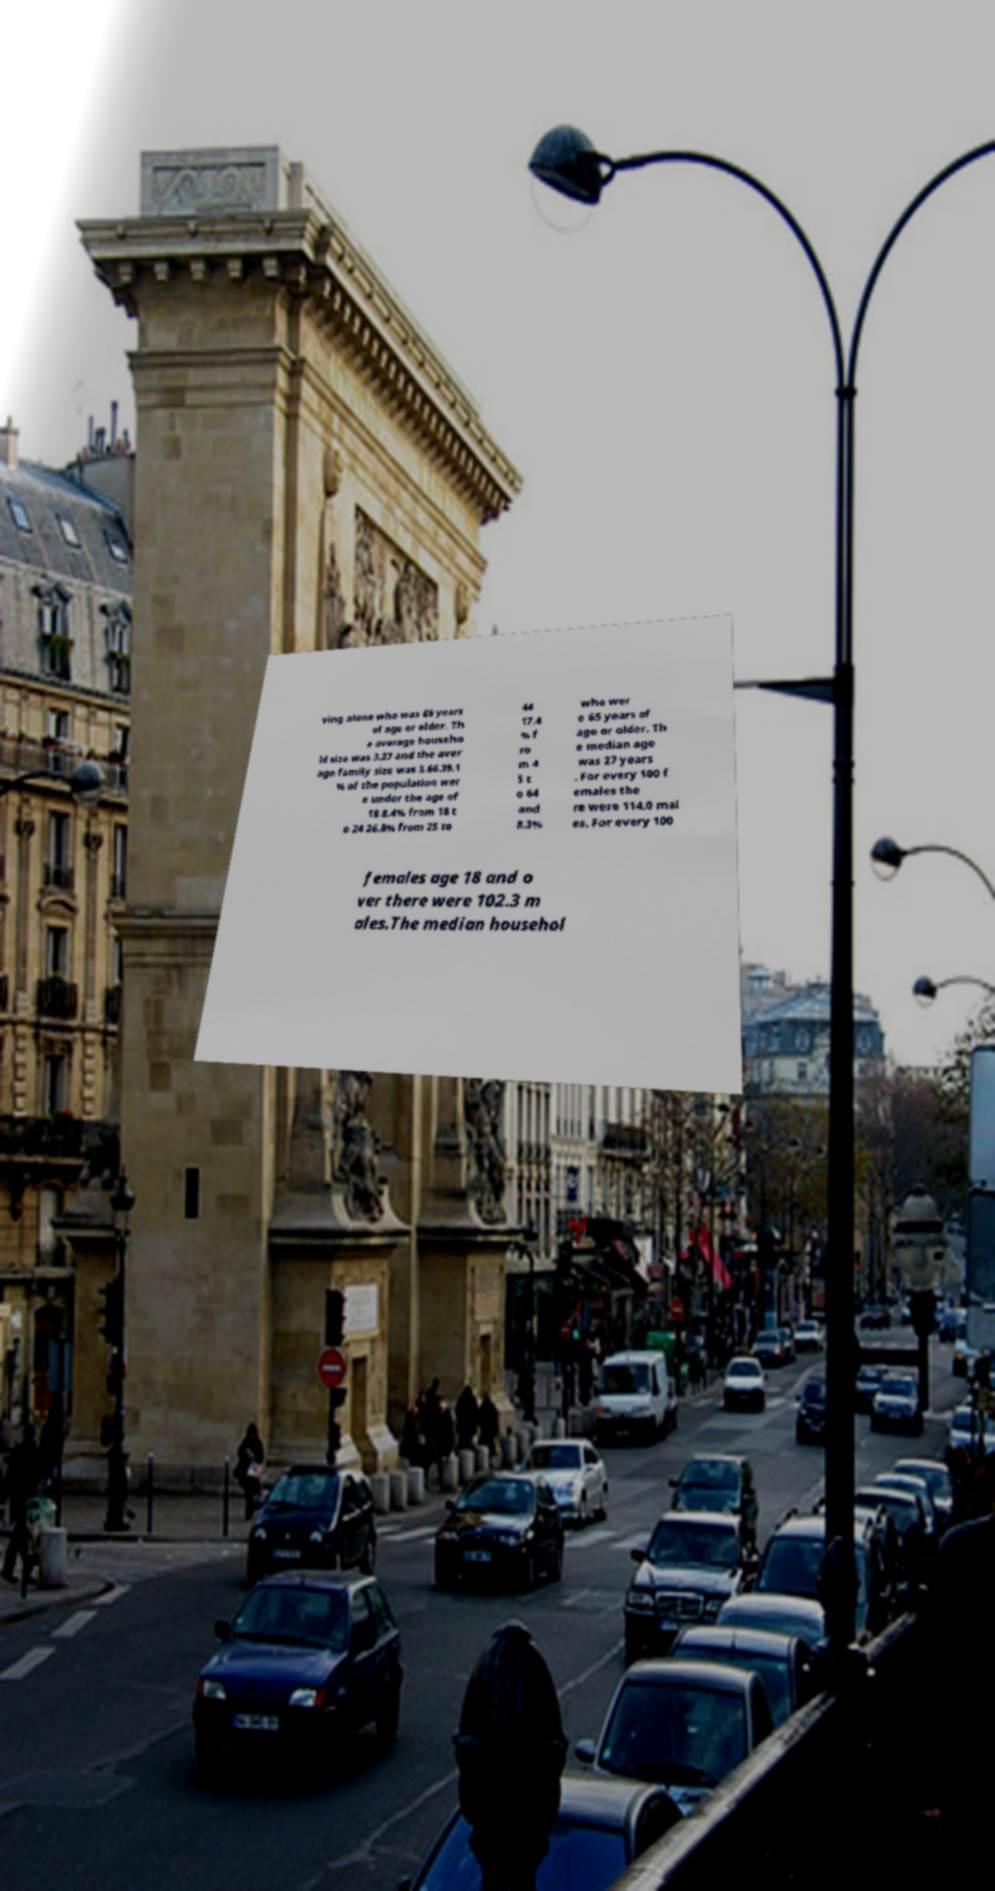Please identify and transcribe the text found in this image. ving alone who was 65 years of age or older. Th e average househo ld size was 3.27 and the aver age family size was 3.66.39.1 % of the population wer e under the age of 18 8.4% from 18 t o 24 26.8% from 25 to 44 17.4 % f ro m 4 5 t o 64 and 8.3% who wer e 65 years of age or older. Th e median age was 27 years . For every 100 f emales the re were 114.0 mal es. For every 100 females age 18 and o ver there were 102.3 m ales.The median househol 